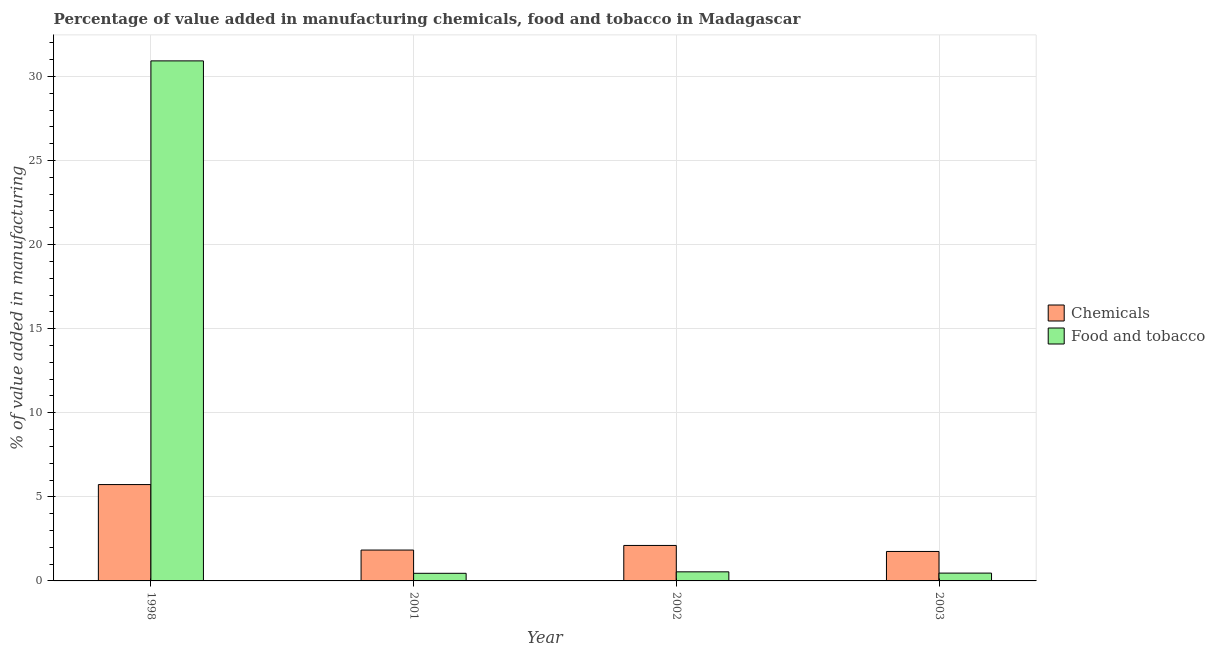How many groups of bars are there?
Keep it short and to the point. 4. Are the number of bars on each tick of the X-axis equal?
Give a very brief answer. Yes. How many bars are there on the 1st tick from the left?
Make the answer very short. 2. In how many cases, is the number of bars for a given year not equal to the number of legend labels?
Your answer should be very brief. 0. What is the value added by manufacturing food and tobacco in 2003?
Provide a short and direct response. 0.46. Across all years, what is the maximum value added by  manufacturing chemicals?
Offer a very short reply. 5.73. Across all years, what is the minimum value added by  manufacturing chemicals?
Keep it short and to the point. 1.75. In which year was the value added by  manufacturing chemicals maximum?
Offer a very short reply. 1998. What is the total value added by manufacturing food and tobacco in the graph?
Provide a succinct answer. 32.38. What is the difference between the value added by manufacturing food and tobacco in 1998 and that in 2002?
Make the answer very short. 30.38. What is the difference between the value added by manufacturing food and tobacco in 2001 and the value added by  manufacturing chemicals in 1998?
Make the answer very short. -30.47. What is the average value added by  manufacturing chemicals per year?
Provide a short and direct response. 2.86. In how many years, is the value added by manufacturing food and tobacco greater than 16 %?
Make the answer very short. 1. What is the ratio of the value added by manufacturing food and tobacco in 1998 to that in 2002?
Ensure brevity in your answer.  57.21. Is the value added by manufacturing food and tobacco in 1998 less than that in 2002?
Provide a succinct answer. No. What is the difference between the highest and the second highest value added by  manufacturing chemicals?
Ensure brevity in your answer.  3.62. What is the difference between the highest and the lowest value added by manufacturing food and tobacco?
Your response must be concise. 30.47. In how many years, is the value added by  manufacturing chemicals greater than the average value added by  manufacturing chemicals taken over all years?
Your answer should be very brief. 1. What does the 2nd bar from the left in 1998 represents?
Keep it short and to the point. Food and tobacco. What does the 1st bar from the right in 2001 represents?
Your answer should be very brief. Food and tobacco. What is the difference between two consecutive major ticks on the Y-axis?
Keep it short and to the point. 5. Are the values on the major ticks of Y-axis written in scientific E-notation?
Your answer should be very brief. No. Does the graph contain any zero values?
Offer a very short reply. No. Where does the legend appear in the graph?
Keep it short and to the point. Center right. What is the title of the graph?
Your answer should be compact. Percentage of value added in manufacturing chemicals, food and tobacco in Madagascar. What is the label or title of the Y-axis?
Provide a succinct answer. % of value added in manufacturing. What is the % of value added in manufacturing of Chemicals in 1998?
Make the answer very short. 5.73. What is the % of value added in manufacturing in Food and tobacco in 1998?
Keep it short and to the point. 30.92. What is the % of value added in manufacturing in Chemicals in 2001?
Your answer should be very brief. 1.84. What is the % of value added in manufacturing in Food and tobacco in 2001?
Provide a short and direct response. 0.45. What is the % of value added in manufacturing of Chemicals in 2002?
Make the answer very short. 2.11. What is the % of value added in manufacturing of Food and tobacco in 2002?
Offer a terse response. 0.54. What is the % of value added in manufacturing in Chemicals in 2003?
Provide a succinct answer. 1.75. What is the % of value added in manufacturing of Food and tobacco in 2003?
Offer a terse response. 0.46. Across all years, what is the maximum % of value added in manufacturing in Chemicals?
Ensure brevity in your answer.  5.73. Across all years, what is the maximum % of value added in manufacturing in Food and tobacco?
Keep it short and to the point. 30.92. Across all years, what is the minimum % of value added in manufacturing of Chemicals?
Make the answer very short. 1.75. Across all years, what is the minimum % of value added in manufacturing in Food and tobacco?
Make the answer very short. 0.45. What is the total % of value added in manufacturing in Chemicals in the graph?
Provide a succinct answer. 11.43. What is the total % of value added in manufacturing in Food and tobacco in the graph?
Make the answer very short. 32.38. What is the difference between the % of value added in manufacturing in Chemicals in 1998 and that in 2001?
Provide a short and direct response. 3.89. What is the difference between the % of value added in manufacturing of Food and tobacco in 1998 and that in 2001?
Your response must be concise. 30.47. What is the difference between the % of value added in manufacturing of Chemicals in 1998 and that in 2002?
Your answer should be very brief. 3.62. What is the difference between the % of value added in manufacturing in Food and tobacco in 1998 and that in 2002?
Your answer should be very brief. 30.38. What is the difference between the % of value added in manufacturing in Chemicals in 1998 and that in 2003?
Offer a very short reply. 3.98. What is the difference between the % of value added in manufacturing of Food and tobacco in 1998 and that in 2003?
Make the answer very short. 30.46. What is the difference between the % of value added in manufacturing of Chemicals in 2001 and that in 2002?
Provide a short and direct response. -0.27. What is the difference between the % of value added in manufacturing of Food and tobacco in 2001 and that in 2002?
Give a very brief answer. -0.09. What is the difference between the % of value added in manufacturing of Chemicals in 2001 and that in 2003?
Your answer should be compact. 0.08. What is the difference between the % of value added in manufacturing in Food and tobacco in 2001 and that in 2003?
Your answer should be compact. -0.01. What is the difference between the % of value added in manufacturing of Chemicals in 2002 and that in 2003?
Provide a succinct answer. 0.36. What is the difference between the % of value added in manufacturing in Food and tobacco in 2002 and that in 2003?
Your answer should be very brief. 0.08. What is the difference between the % of value added in manufacturing of Chemicals in 1998 and the % of value added in manufacturing of Food and tobacco in 2001?
Keep it short and to the point. 5.28. What is the difference between the % of value added in manufacturing of Chemicals in 1998 and the % of value added in manufacturing of Food and tobacco in 2002?
Give a very brief answer. 5.19. What is the difference between the % of value added in manufacturing of Chemicals in 1998 and the % of value added in manufacturing of Food and tobacco in 2003?
Keep it short and to the point. 5.26. What is the difference between the % of value added in manufacturing of Chemicals in 2001 and the % of value added in manufacturing of Food and tobacco in 2002?
Offer a terse response. 1.3. What is the difference between the % of value added in manufacturing of Chemicals in 2001 and the % of value added in manufacturing of Food and tobacco in 2003?
Your answer should be compact. 1.37. What is the difference between the % of value added in manufacturing in Chemicals in 2002 and the % of value added in manufacturing in Food and tobacco in 2003?
Offer a very short reply. 1.64. What is the average % of value added in manufacturing in Chemicals per year?
Make the answer very short. 2.86. What is the average % of value added in manufacturing of Food and tobacco per year?
Your answer should be very brief. 8.1. In the year 1998, what is the difference between the % of value added in manufacturing of Chemicals and % of value added in manufacturing of Food and tobacco?
Provide a succinct answer. -25.2. In the year 2001, what is the difference between the % of value added in manufacturing in Chemicals and % of value added in manufacturing in Food and tobacco?
Your answer should be compact. 1.38. In the year 2002, what is the difference between the % of value added in manufacturing of Chemicals and % of value added in manufacturing of Food and tobacco?
Make the answer very short. 1.57. In the year 2003, what is the difference between the % of value added in manufacturing in Chemicals and % of value added in manufacturing in Food and tobacco?
Make the answer very short. 1.29. What is the ratio of the % of value added in manufacturing in Chemicals in 1998 to that in 2001?
Offer a terse response. 3.12. What is the ratio of the % of value added in manufacturing of Food and tobacco in 1998 to that in 2001?
Your answer should be very brief. 68.27. What is the ratio of the % of value added in manufacturing of Chemicals in 1998 to that in 2002?
Keep it short and to the point. 2.72. What is the ratio of the % of value added in manufacturing in Food and tobacco in 1998 to that in 2002?
Keep it short and to the point. 57.21. What is the ratio of the % of value added in manufacturing of Chemicals in 1998 to that in 2003?
Your response must be concise. 3.27. What is the ratio of the % of value added in manufacturing of Food and tobacco in 1998 to that in 2003?
Offer a very short reply. 66.52. What is the ratio of the % of value added in manufacturing in Chemicals in 2001 to that in 2002?
Your answer should be very brief. 0.87. What is the ratio of the % of value added in manufacturing in Food and tobacco in 2001 to that in 2002?
Provide a short and direct response. 0.84. What is the ratio of the % of value added in manufacturing in Chemicals in 2001 to that in 2003?
Your response must be concise. 1.05. What is the ratio of the % of value added in manufacturing of Food and tobacco in 2001 to that in 2003?
Offer a terse response. 0.97. What is the ratio of the % of value added in manufacturing of Chemicals in 2002 to that in 2003?
Make the answer very short. 1.2. What is the ratio of the % of value added in manufacturing in Food and tobacco in 2002 to that in 2003?
Make the answer very short. 1.16. What is the difference between the highest and the second highest % of value added in manufacturing in Chemicals?
Your answer should be very brief. 3.62. What is the difference between the highest and the second highest % of value added in manufacturing of Food and tobacco?
Give a very brief answer. 30.38. What is the difference between the highest and the lowest % of value added in manufacturing of Chemicals?
Ensure brevity in your answer.  3.98. What is the difference between the highest and the lowest % of value added in manufacturing of Food and tobacco?
Offer a very short reply. 30.47. 